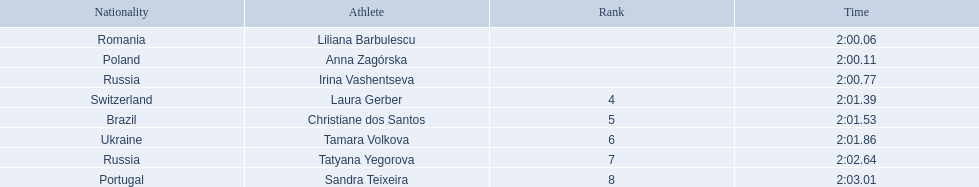Which athletes competed in the 2003 summer universiade - women's 800 metres? Liliana Barbulescu, Anna Zagórska, Irina Vashentseva, Laura Gerber, Christiane dos Santos, Tamara Volkova, Tatyana Yegorova, Sandra Teixeira. Of these, which are from poland? Anna Zagórska. What is her time? 2:00.11. 